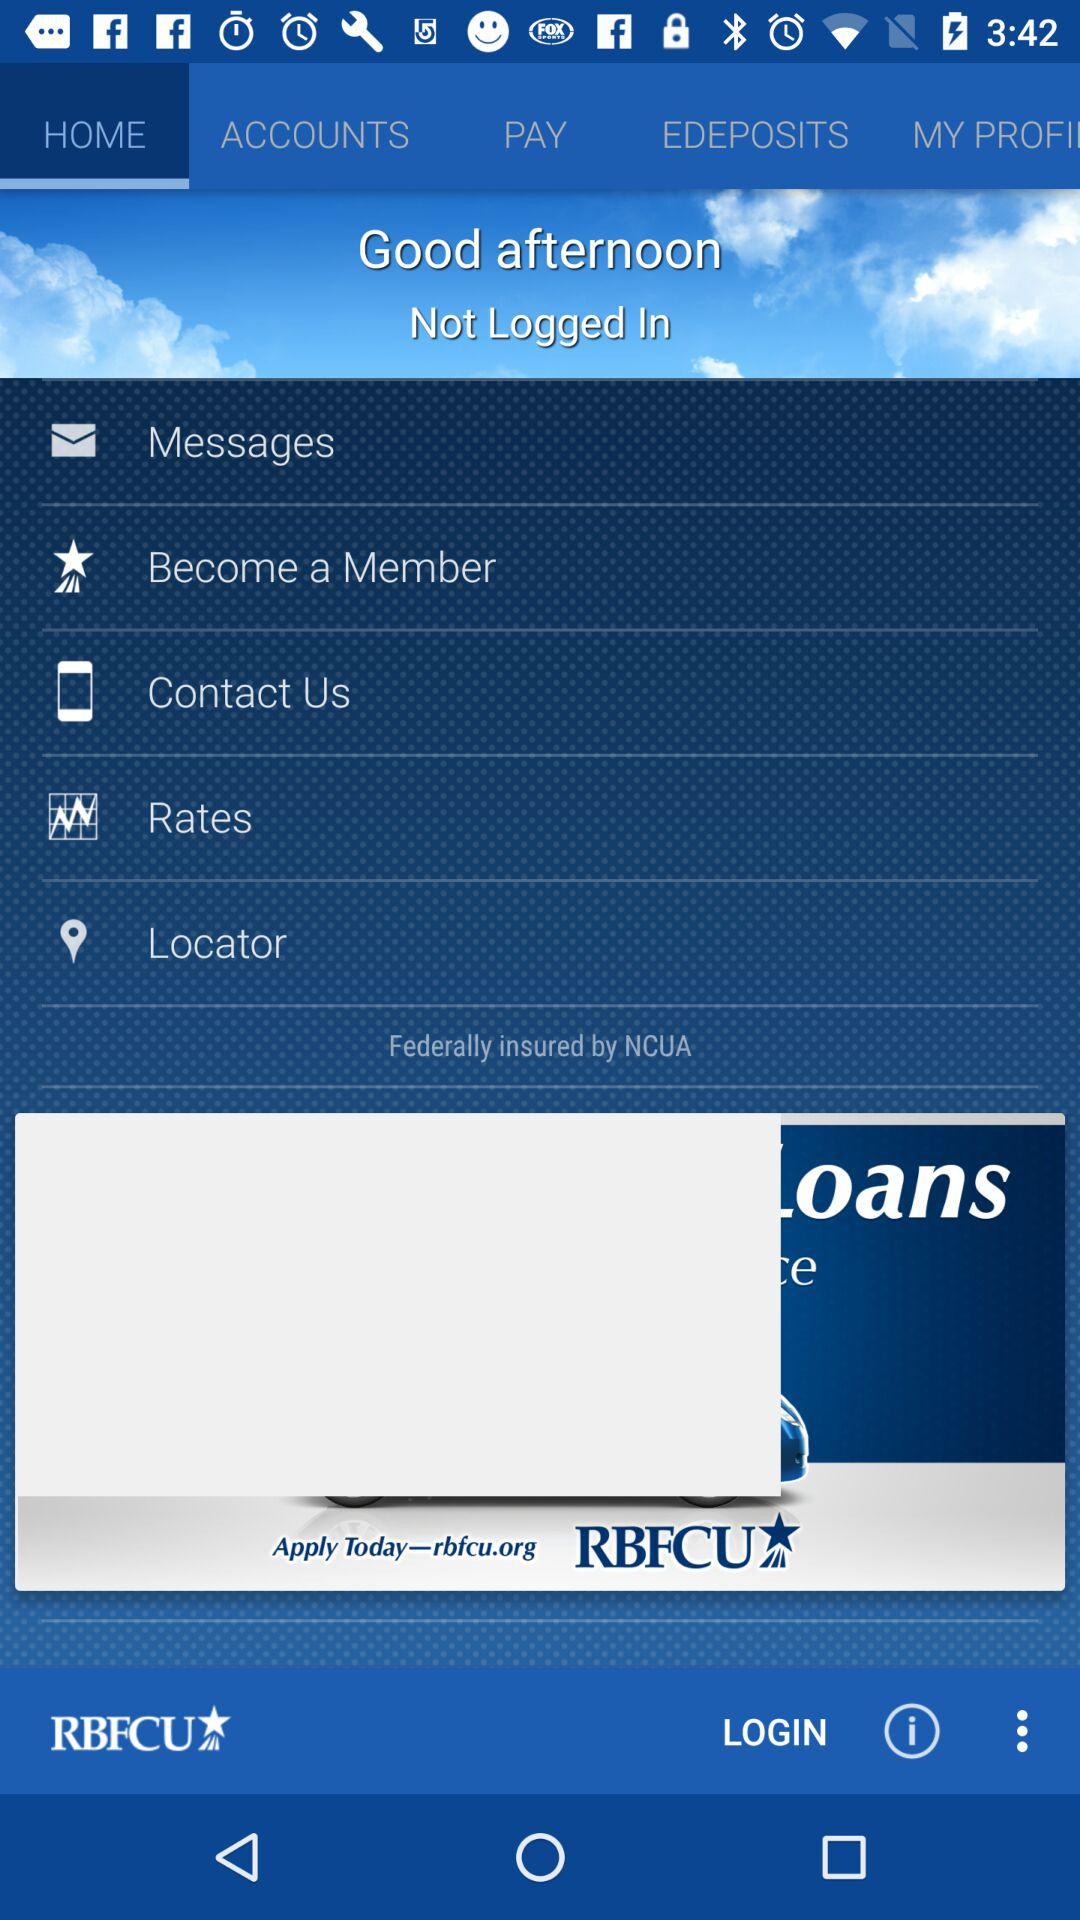What agency has federally insured the application? The application is federally insured by NCUA. 